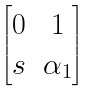<formula> <loc_0><loc_0><loc_500><loc_500>\begin{bmatrix} 0 & 1 \\ s & \alpha _ { 1 } \end{bmatrix}</formula> 